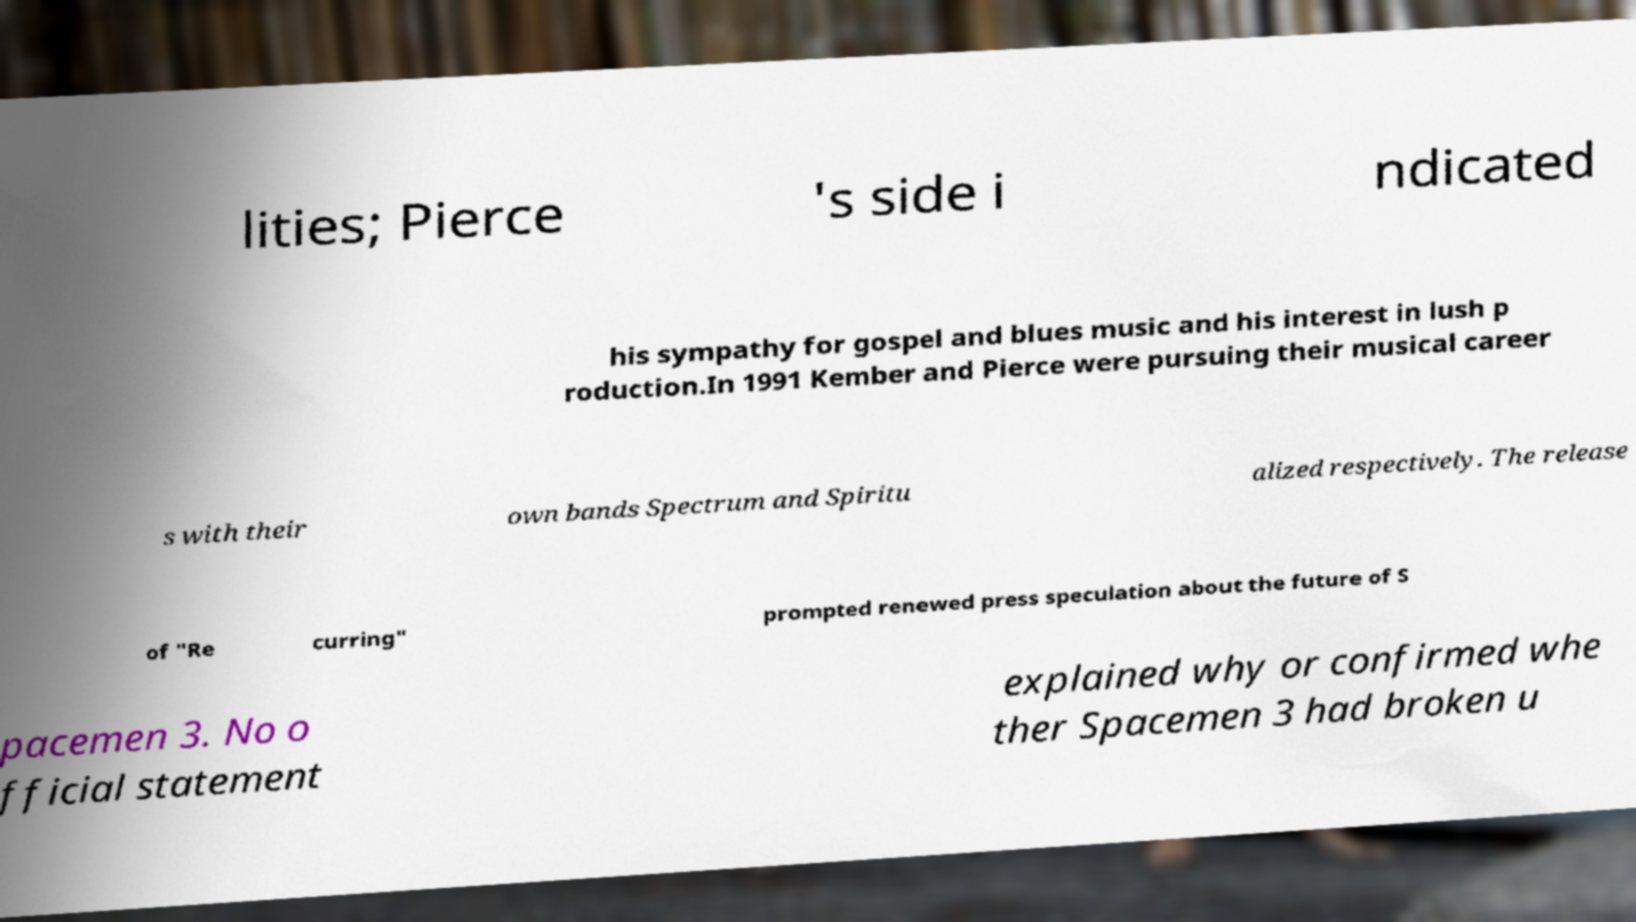Please identify and transcribe the text found in this image. lities; Pierce 's side i ndicated his sympathy for gospel and blues music and his interest in lush p roduction.In 1991 Kember and Pierce were pursuing their musical career s with their own bands Spectrum and Spiritu alized respectively. The release of "Re curring" prompted renewed press speculation about the future of S pacemen 3. No o fficial statement explained why or confirmed whe ther Spacemen 3 had broken u 